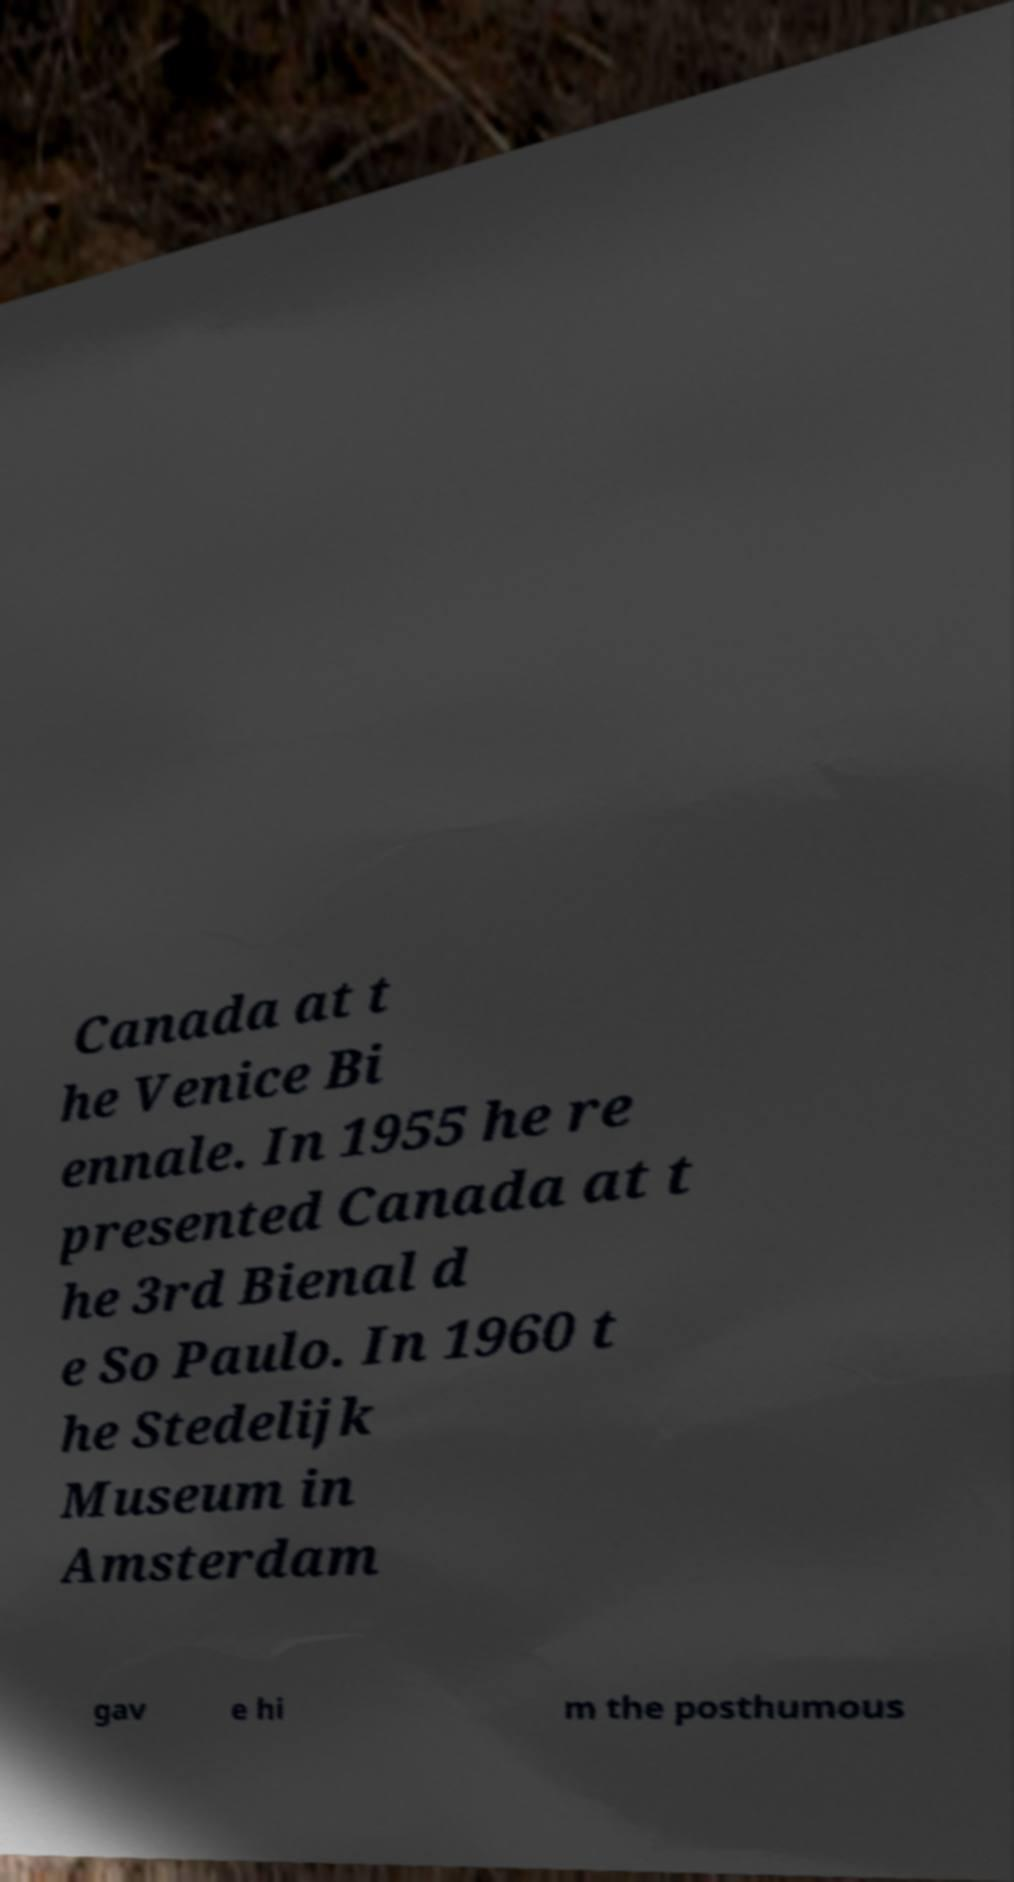Can you read and provide the text displayed in the image?This photo seems to have some interesting text. Can you extract and type it out for me? Canada at t he Venice Bi ennale. In 1955 he re presented Canada at t he 3rd Bienal d e So Paulo. In 1960 t he Stedelijk Museum in Amsterdam gav e hi m the posthumous 